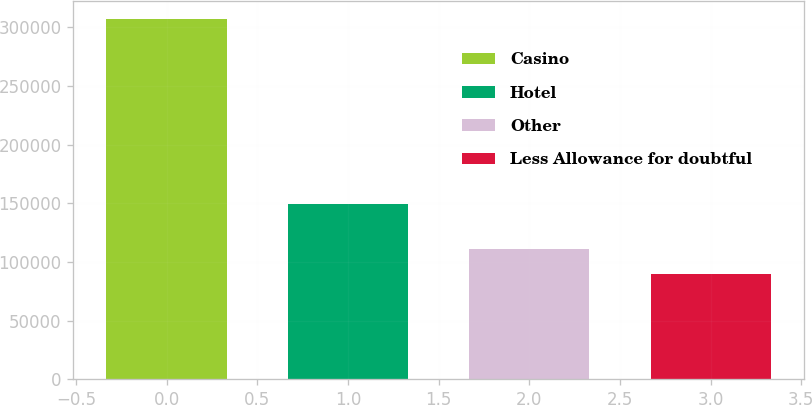<chart> <loc_0><loc_0><loc_500><loc_500><bar_chart><fcel>Casino<fcel>Hotel<fcel>Other<fcel>Less Allowance for doubtful<nl><fcel>307152<fcel>149268<fcel>111357<fcel>89602<nl></chart> 